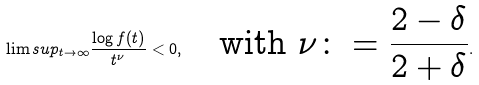Convert formula to latex. <formula><loc_0><loc_0><loc_500><loc_500>\lim s u p _ { t \to \infty } \frac { \log f ( t ) } { t ^ { \nu } } < 0 , \quad \text {with $\nu\colon=\frac{2-\delta}{2+\delta}$} .</formula> 